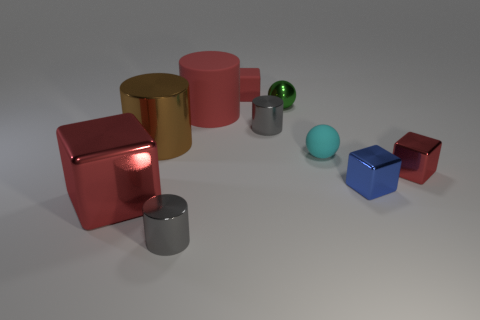Do the metal cube behind the small blue shiny thing and the tiny cube on the left side of the small cyan matte sphere have the same color?
Offer a very short reply. Yes. What is the size of the metal cube that is to the left of the tiny thing that is to the left of the small red block that is behind the green metallic ball?
Your response must be concise. Large. The big rubber object that is the same shape as the brown metal thing is what color?
Keep it short and to the point. Red. Are there more metallic objects that are to the right of the cyan matte thing than large red things?
Keep it short and to the point. No. There is a large red rubber thing; is it the same shape as the big metallic thing behind the big shiny block?
Your answer should be very brief. Yes. Is there anything else that is the same size as the cyan rubber object?
Your response must be concise. Yes. There is another rubber thing that is the same shape as the brown thing; what size is it?
Make the answer very short. Large. Are there more small yellow metallic objects than cylinders?
Offer a terse response. No. Is the shape of the big red shiny object the same as the large brown shiny thing?
Ensure brevity in your answer.  No. What material is the tiny red object on the left side of the gray cylinder behind the small cyan ball made of?
Make the answer very short. Rubber. 